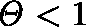<formula> <loc_0><loc_0><loc_500><loc_500>\Theta < 1</formula> 